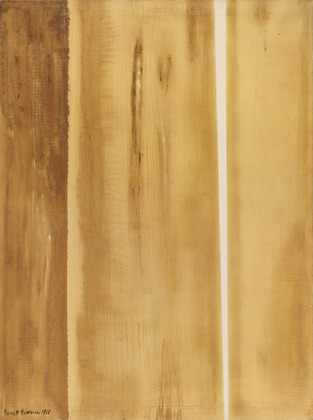Could you offer some historical context about abstract expressionism? Abstract expressionism emerged in the mid-20th century, mainly in New York, becoming the first American movement to gain international stature. Artists of this genre emphasized spontaneous, automatic, or subconscious creation. They often sought to express profound emotional or spiritual experiences through their works. This movement includes various styles, from the dramatic, gestural brushstrokes of action painting to the serene, expansive fields of color seen in color field painting. This period marked a significant shift in the art world, emphasizing personal expression and breaking away from traditional forms and subjects. 